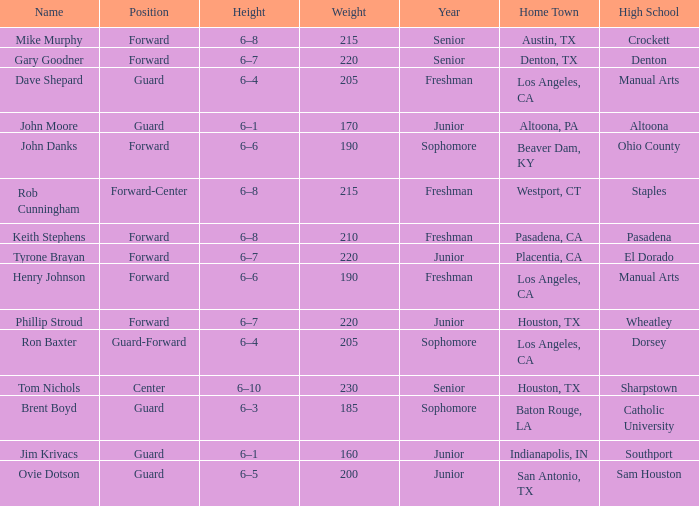What is the Home Town with a Year of freshman, and a Height with 6–6? Los Angeles, CA. 